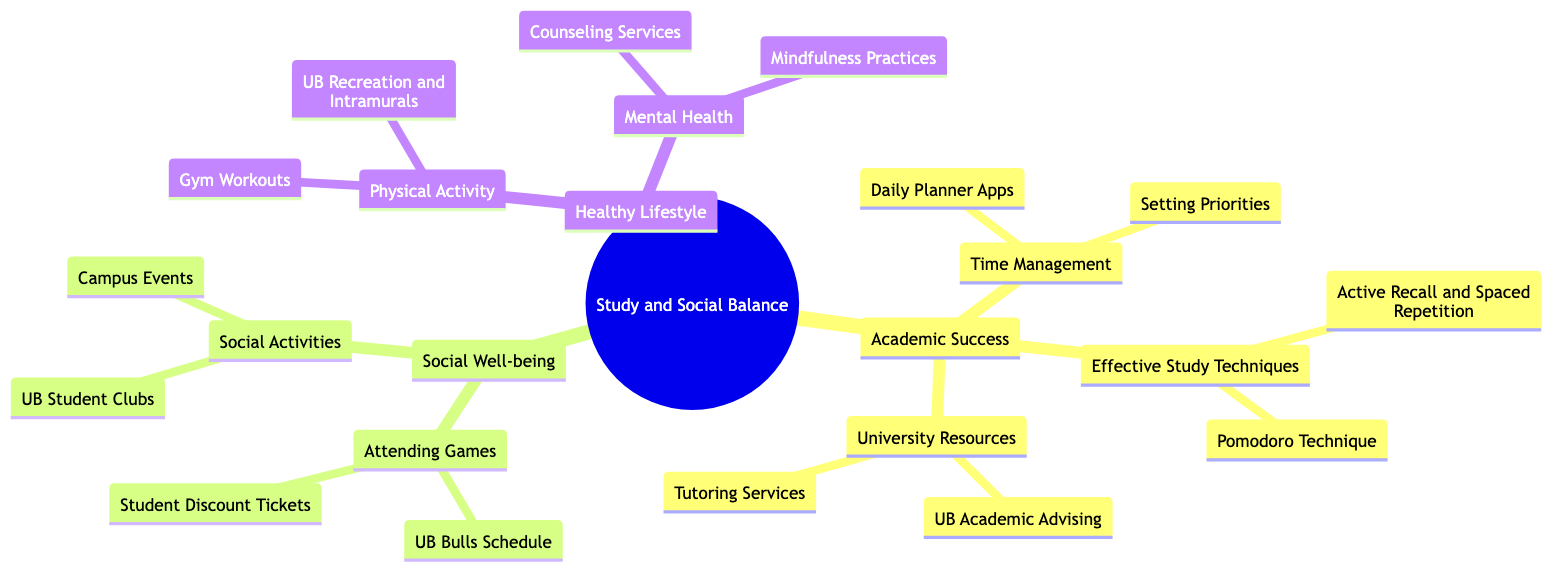What is the central theme of the mind map? The central node of the mind map states "Study and Social Balance: How to Manage Academics and Enjoy University Athletics," which defines the overall focus of the diagram.
Answer: Study and Social Balance: How to Manage Academics and Enjoy University Athletics How many branches are under "Academic Success"? The "Academic Success" branch has three sub-branches: "Time Management," "Effective Study Techniques," and "University Resources." Therefore, there are three branches.
Answer: 3 Which branch focuses on activities outside of academics? The "Social Well-being" branch is specifically concerned with activities that relate to social interactions and enjoyment outside of academic studies.
Answer: Social Well-being What effective study technique is listed under "Effective Study Techniques"? Among the sub-branches under "Effective Study Techniques," the "Pomodoro Technique" is mentioned as one of the strategies for studying effectively.
Answer: Pomodoro Technique Which aspect of health is associated with "UB Recreation and Intramurals"? "Physical Activity" is the branch under "Healthy Lifestyle" that includes "UB Recreation and Intramurals," relating to maintaining a physically active lifestyle.
Answer: Physical Activity What university resource is listed for academic support? The branch "University Resources" includes "UB Academic Advising," which serves as an academic support resource for students at the university.
Answer: UB Academic Advising How many sub-branches does "Healthy Lifestyle" have? The "Healthy Lifestyle" branch has two sub-branches: "Physical Activity" and "Mental Health," making a total of two sub-branches.
Answer: 2 Which option relates to attending UB Bulls games? The "Student Discount Tickets" sub-branch falls under "Attending Games," which directly relates to attending games for the UB Bulls.
Answer: Student Discount Tickets What is one mental health service listed? "Counseling Services" is provided as a mental health service within the "Mental Health" sub-branch under "Healthy Lifestyle."
Answer: Counseling Services 